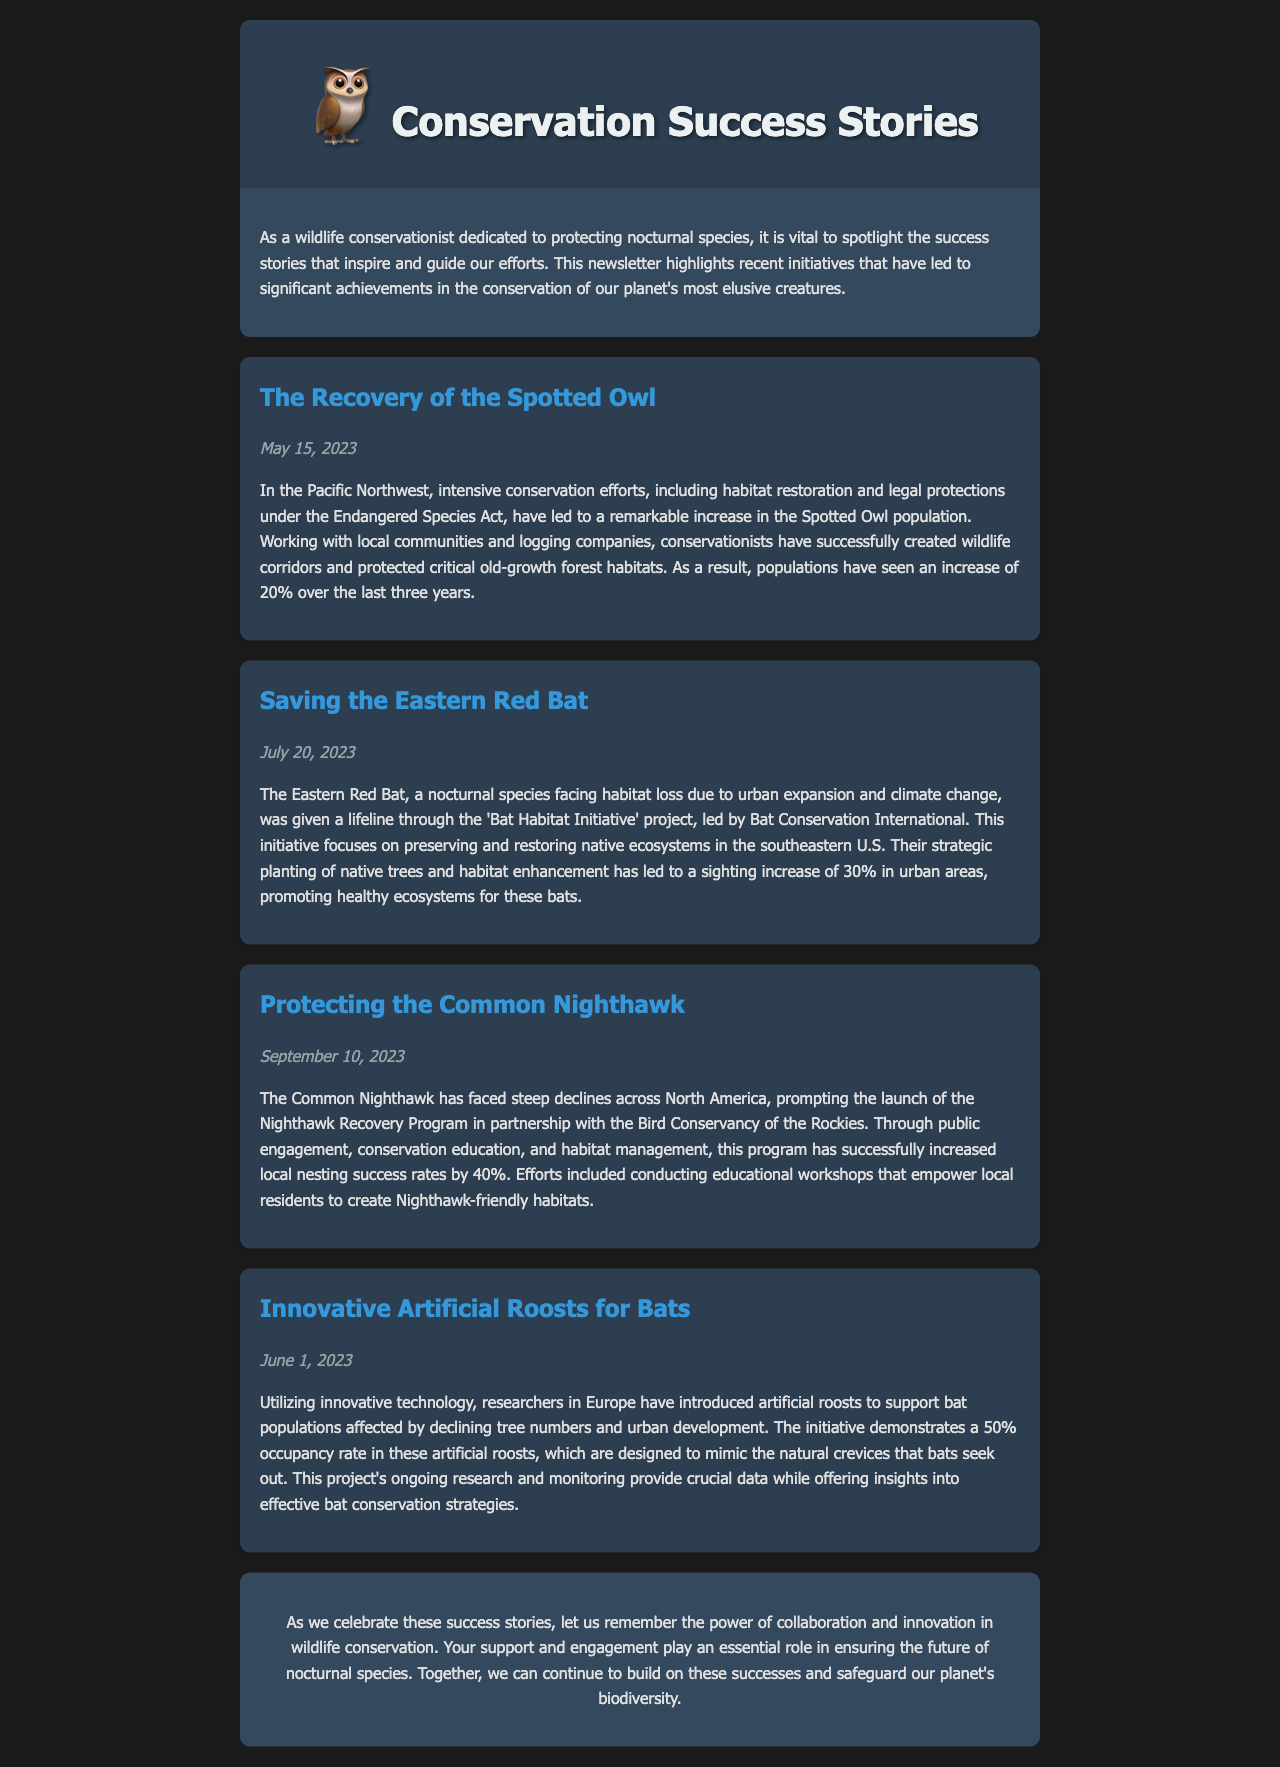What is the title of the newsletter? The title is highlighted at the top of the document.
Answer: Conservation Success Stories: Nocturnal Species Protection What date was the story about the Spotted Owl published? The publication date is included in each success story section.
Answer: May 15, 2023 What was the percentage increase in the Spotted Owl population? The document states the percentage increase as part of the success story details.
Answer: 20% What initiative helped the Eastern Red Bat? The specific initiative is mentioned in the success story section for the Eastern Red Bat.
Answer: Bat Habitat Initiative By what percentage did local nesting success rates increase for the Common Nighthawk? The percentage is specifically noted in the paragraph regarding the Nighthawk Recovery Program.
Answer: 40% What innovative technology was used in the project for bats in Europe? The document mentions the technology in the context of supporting bat populations.
Answer: Artificial roosts Which conservation organization partnered in the Nighthawk Recovery Program? The partnership for this program is mentioned in the success story section.
Answer: Bird Conservancy of the Rockies How much was the occupancy rate in artificial roosts for bats? The occupancy rate is included for the artificial roosts initiative described in the newsletter.
Answer: 50% 